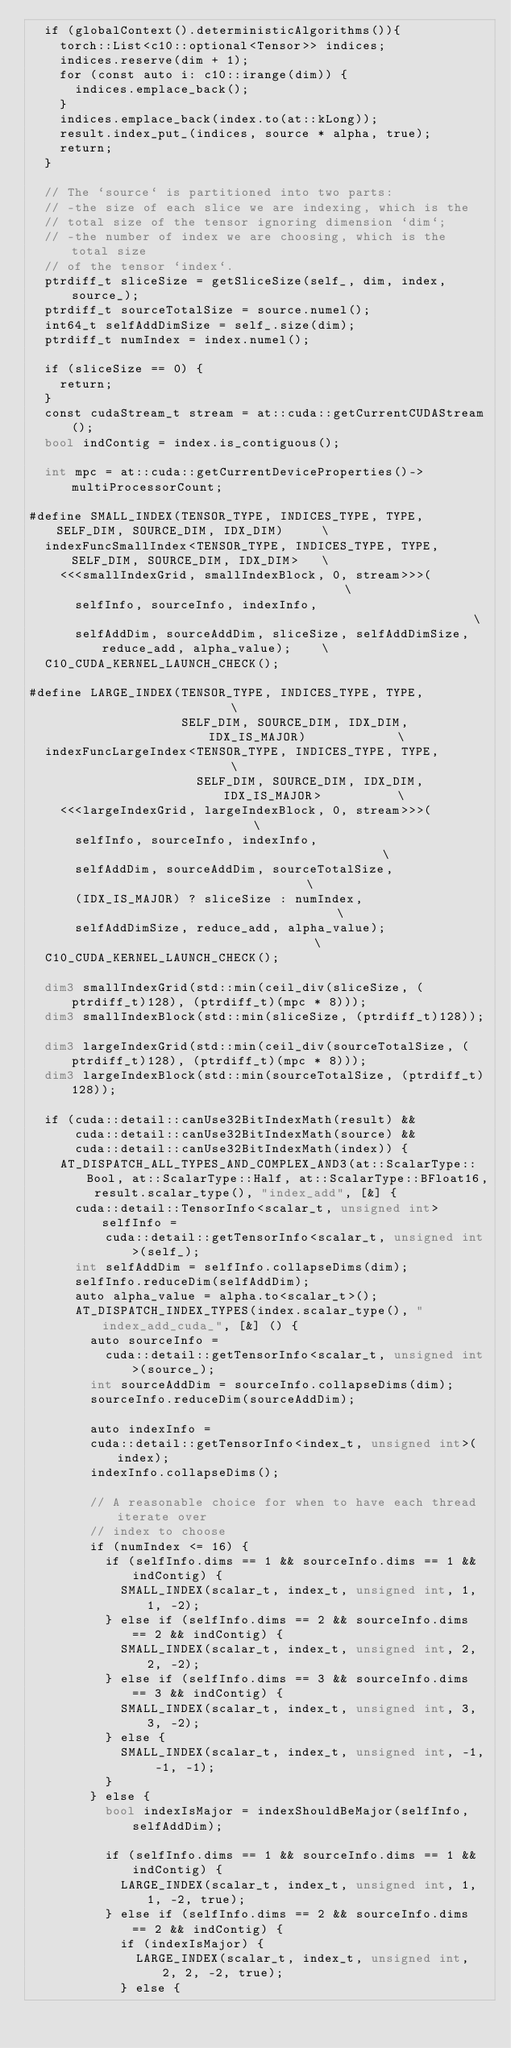<code> <loc_0><loc_0><loc_500><loc_500><_Cuda_>  if (globalContext().deterministicAlgorithms()){
    torch::List<c10::optional<Tensor>> indices;
    indices.reserve(dim + 1);
    for (const auto i: c10::irange(dim)) {
      indices.emplace_back();
    }
    indices.emplace_back(index.to(at::kLong));
    result.index_put_(indices, source * alpha, true);
    return;
  }

  // The `source` is partitioned into two parts:
  // -the size of each slice we are indexing, which is the
  // total size of the tensor ignoring dimension `dim`;
  // -the number of index we are choosing, which is the total size
  // of the tensor `index`.
  ptrdiff_t sliceSize = getSliceSize(self_, dim, index, source_);
  ptrdiff_t sourceTotalSize = source.numel();
  int64_t selfAddDimSize = self_.size(dim);
  ptrdiff_t numIndex = index.numel();

  if (sliceSize == 0) {
    return;
  }
  const cudaStream_t stream = at::cuda::getCurrentCUDAStream();
  bool indContig = index.is_contiguous();

  int mpc = at::cuda::getCurrentDeviceProperties()->multiProcessorCount;

#define SMALL_INDEX(TENSOR_TYPE, INDICES_TYPE, TYPE, SELF_DIM, SOURCE_DIM, IDX_DIM)     \
  indexFuncSmallIndex<TENSOR_TYPE, INDICES_TYPE, TYPE, SELF_DIM, SOURCE_DIM, IDX_DIM>   \
    <<<smallIndexGrid, smallIndexBlock, 0, stream>>>(                                   \
      selfInfo, sourceInfo, indexInfo,                                                  \
      selfAddDim, sourceAddDim, sliceSize, selfAddDimSize, reduce_add, alpha_value);    \
  C10_CUDA_KERNEL_LAUNCH_CHECK();

#define LARGE_INDEX(TENSOR_TYPE, INDICES_TYPE, TYPE,                        \
                    SELF_DIM, SOURCE_DIM, IDX_DIM, IDX_IS_MAJOR)            \
  indexFuncLargeIndex<TENSOR_TYPE, INDICES_TYPE, TYPE,                      \
                      SELF_DIM, SOURCE_DIM, IDX_DIM, IDX_IS_MAJOR>          \
    <<<largeIndexGrid, largeIndexBlock, 0, stream>>>(                       \
      selfInfo, sourceInfo, indexInfo,                                      \
      selfAddDim, sourceAddDim, sourceTotalSize,                            \
      (IDX_IS_MAJOR) ? sliceSize : numIndex,                                \
      selfAddDimSize, reduce_add, alpha_value);                             \
  C10_CUDA_KERNEL_LAUNCH_CHECK();

  dim3 smallIndexGrid(std::min(ceil_div(sliceSize, (ptrdiff_t)128), (ptrdiff_t)(mpc * 8)));
  dim3 smallIndexBlock(std::min(sliceSize, (ptrdiff_t)128));

  dim3 largeIndexGrid(std::min(ceil_div(sourceTotalSize, (ptrdiff_t)128), (ptrdiff_t)(mpc * 8)));
  dim3 largeIndexBlock(std::min(sourceTotalSize, (ptrdiff_t)128));

  if (cuda::detail::canUse32BitIndexMath(result) &&
      cuda::detail::canUse32BitIndexMath(source) &&
      cuda::detail::canUse32BitIndexMath(index)) {
    AT_DISPATCH_ALL_TYPES_AND_COMPLEX_AND3(at::ScalarType::Bool, at::ScalarType::Half, at::ScalarType::BFloat16, result.scalar_type(), "index_add", [&] {
      cuda::detail::TensorInfo<scalar_t, unsigned int> selfInfo =
          cuda::detail::getTensorInfo<scalar_t, unsigned int>(self_);
      int selfAddDim = selfInfo.collapseDims(dim);
      selfInfo.reduceDim(selfAddDim);
      auto alpha_value = alpha.to<scalar_t>();
      AT_DISPATCH_INDEX_TYPES(index.scalar_type(), "index_add_cuda_", [&] () {
        auto sourceInfo =
          cuda::detail::getTensorInfo<scalar_t, unsigned int>(source_);
        int sourceAddDim = sourceInfo.collapseDims(dim);
        sourceInfo.reduceDim(sourceAddDim);

        auto indexInfo =
        cuda::detail::getTensorInfo<index_t, unsigned int>(index);
        indexInfo.collapseDims();

        // A reasonable choice for when to have each thread iterate over
        // index to choose
        if (numIndex <= 16) {
          if (selfInfo.dims == 1 && sourceInfo.dims == 1 && indContig) {
            SMALL_INDEX(scalar_t, index_t, unsigned int, 1, 1, -2);
          } else if (selfInfo.dims == 2 && sourceInfo.dims == 2 && indContig) {
            SMALL_INDEX(scalar_t, index_t, unsigned int, 2, 2, -2);
          } else if (selfInfo.dims == 3 && sourceInfo.dims == 3 && indContig) {
            SMALL_INDEX(scalar_t, index_t, unsigned int, 3, 3, -2);
          } else {
            SMALL_INDEX(scalar_t, index_t, unsigned int, -1, -1, -1);
          }
        } else {
          bool indexIsMajor = indexShouldBeMajor(selfInfo, selfAddDim);

          if (selfInfo.dims == 1 && sourceInfo.dims == 1 && indContig) {
            LARGE_INDEX(scalar_t, index_t, unsigned int, 1, 1, -2, true);
          } else if (selfInfo.dims == 2 && sourceInfo.dims == 2 && indContig) {
            if (indexIsMajor) {
              LARGE_INDEX(scalar_t, index_t, unsigned int, 2, 2, -2, true);
            } else {</code> 